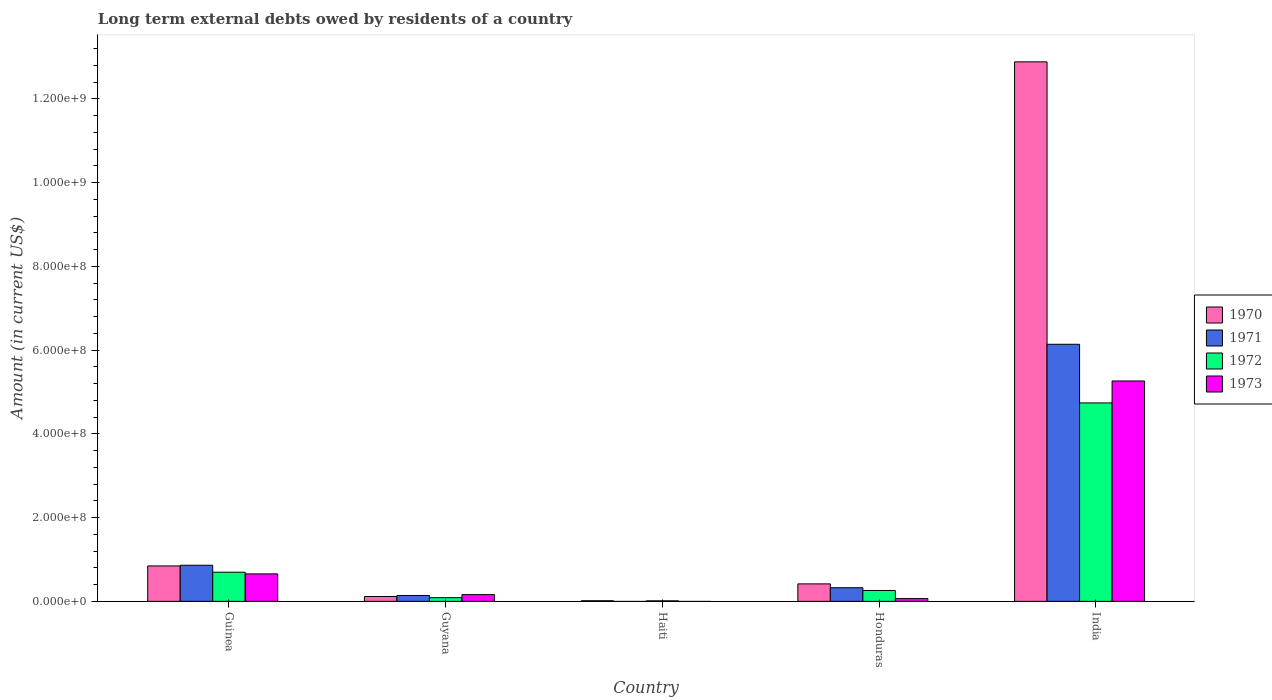Are the number of bars per tick equal to the number of legend labels?
Provide a succinct answer. No. Are the number of bars on each tick of the X-axis equal?
Provide a succinct answer. No. What is the label of the 5th group of bars from the left?
Provide a short and direct response. India. What is the amount of long-term external debts owed by residents in 1973 in Honduras?
Keep it short and to the point. 6.62e+06. Across all countries, what is the maximum amount of long-term external debts owed by residents in 1972?
Your answer should be compact. 4.74e+08. Across all countries, what is the minimum amount of long-term external debts owed by residents in 1971?
Offer a terse response. 0. In which country was the amount of long-term external debts owed by residents in 1971 maximum?
Provide a succinct answer. India. What is the total amount of long-term external debts owed by residents in 1971 in the graph?
Offer a terse response. 7.47e+08. What is the difference between the amount of long-term external debts owed by residents in 1971 in Guinea and that in India?
Your answer should be compact. -5.28e+08. What is the difference between the amount of long-term external debts owed by residents in 1971 in India and the amount of long-term external debts owed by residents in 1970 in Guyana?
Make the answer very short. 6.02e+08. What is the average amount of long-term external debts owed by residents in 1970 per country?
Give a very brief answer. 2.86e+08. What is the difference between the amount of long-term external debts owed by residents of/in 1970 and amount of long-term external debts owed by residents of/in 1971 in Guinea?
Ensure brevity in your answer.  -1.66e+06. In how many countries, is the amount of long-term external debts owed by residents in 1973 greater than 160000000 US$?
Offer a very short reply. 1. What is the ratio of the amount of long-term external debts owed by residents in 1970 in Guinea to that in Honduras?
Make the answer very short. 2.03. Is the difference between the amount of long-term external debts owed by residents in 1970 in Guyana and Honduras greater than the difference between the amount of long-term external debts owed by residents in 1971 in Guyana and Honduras?
Ensure brevity in your answer.  No. What is the difference between the highest and the second highest amount of long-term external debts owed by residents in 1973?
Your answer should be very brief. 4.61e+08. What is the difference between the highest and the lowest amount of long-term external debts owed by residents in 1970?
Your response must be concise. 1.29e+09. Is the sum of the amount of long-term external debts owed by residents in 1973 in Guyana and India greater than the maximum amount of long-term external debts owed by residents in 1972 across all countries?
Provide a short and direct response. Yes. Is it the case that in every country, the sum of the amount of long-term external debts owed by residents in 1971 and amount of long-term external debts owed by residents in 1973 is greater than the sum of amount of long-term external debts owed by residents in 1972 and amount of long-term external debts owed by residents in 1970?
Make the answer very short. No. Is it the case that in every country, the sum of the amount of long-term external debts owed by residents in 1972 and amount of long-term external debts owed by residents in 1970 is greater than the amount of long-term external debts owed by residents in 1973?
Offer a very short reply. Yes. Are all the bars in the graph horizontal?
Offer a terse response. No. How many countries are there in the graph?
Make the answer very short. 5. What is the difference between two consecutive major ticks on the Y-axis?
Keep it short and to the point. 2.00e+08. Does the graph contain grids?
Offer a very short reply. No. How many legend labels are there?
Your answer should be very brief. 4. What is the title of the graph?
Keep it short and to the point. Long term external debts owed by residents of a country. What is the label or title of the X-axis?
Your response must be concise. Country. What is the label or title of the Y-axis?
Provide a short and direct response. Amount (in current US$). What is the Amount (in current US$) of 1970 in Guinea?
Make the answer very short. 8.46e+07. What is the Amount (in current US$) in 1971 in Guinea?
Give a very brief answer. 8.63e+07. What is the Amount (in current US$) of 1972 in Guinea?
Make the answer very short. 6.96e+07. What is the Amount (in current US$) of 1973 in Guinea?
Give a very brief answer. 6.56e+07. What is the Amount (in current US$) in 1970 in Guyana?
Make the answer very short. 1.16e+07. What is the Amount (in current US$) in 1971 in Guyana?
Give a very brief answer. 1.40e+07. What is the Amount (in current US$) in 1972 in Guyana?
Offer a very short reply. 8.75e+06. What is the Amount (in current US$) in 1973 in Guyana?
Your answer should be compact. 1.61e+07. What is the Amount (in current US$) in 1970 in Haiti?
Make the answer very short. 1.51e+06. What is the Amount (in current US$) in 1971 in Haiti?
Your answer should be very brief. 0. What is the Amount (in current US$) of 1972 in Haiti?
Provide a succinct answer. 1.24e+06. What is the Amount (in current US$) in 1973 in Haiti?
Ensure brevity in your answer.  0. What is the Amount (in current US$) of 1970 in Honduras?
Provide a short and direct response. 4.17e+07. What is the Amount (in current US$) of 1971 in Honduras?
Keep it short and to the point. 3.26e+07. What is the Amount (in current US$) in 1972 in Honduras?
Offer a very short reply. 2.60e+07. What is the Amount (in current US$) of 1973 in Honduras?
Provide a short and direct response. 6.62e+06. What is the Amount (in current US$) of 1970 in India?
Provide a short and direct response. 1.29e+09. What is the Amount (in current US$) of 1971 in India?
Give a very brief answer. 6.14e+08. What is the Amount (in current US$) in 1972 in India?
Your answer should be compact. 4.74e+08. What is the Amount (in current US$) of 1973 in India?
Your answer should be very brief. 5.26e+08. Across all countries, what is the maximum Amount (in current US$) of 1970?
Your answer should be very brief. 1.29e+09. Across all countries, what is the maximum Amount (in current US$) of 1971?
Provide a short and direct response. 6.14e+08. Across all countries, what is the maximum Amount (in current US$) of 1972?
Keep it short and to the point. 4.74e+08. Across all countries, what is the maximum Amount (in current US$) of 1973?
Your answer should be very brief. 5.26e+08. Across all countries, what is the minimum Amount (in current US$) in 1970?
Keep it short and to the point. 1.51e+06. Across all countries, what is the minimum Amount (in current US$) of 1972?
Make the answer very short. 1.24e+06. Across all countries, what is the minimum Amount (in current US$) of 1973?
Your response must be concise. 0. What is the total Amount (in current US$) of 1970 in the graph?
Offer a very short reply. 1.43e+09. What is the total Amount (in current US$) of 1971 in the graph?
Give a very brief answer. 7.47e+08. What is the total Amount (in current US$) of 1972 in the graph?
Keep it short and to the point. 5.80e+08. What is the total Amount (in current US$) of 1973 in the graph?
Provide a succinct answer. 6.15e+08. What is the difference between the Amount (in current US$) of 1970 in Guinea and that in Guyana?
Offer a terse response. 7.30e+07. What is the difference between the Amount (in current US$) in 1971 in Guinea and that in Guyana?
Offer a terse response. 7.22e+07. What is the difference between the Amount (in current US$) of 1972 in Guinea and that in Guyana?
Your answer should be compact. 6.09e+07. What is the difference between the Amount (in current US$) in 1973 in Guinea and that in Guyana?
Offer a terse response. 4.95e+07. What is the difference between the Amount (in current US$) of 1970 in Guinea and that in Haiti?
Make the answer very short. 8.31e+07. What is the difference between the Amount (in current US$) in 1972 in Guinea and that in Haiti?
Your answer should be very brief. 6.84e+07. What is the difference between the Amount (in current US$) in 1970 in Guinea and that in Honduras?
Provide a short and direct response. 4.29e+07. What is the difference between the Amount (in current US$) of 1971 in Guinea and that in Honduras?
Provide a short and direct response. 5.37e+07. What is the difference between the Amount (in current US$) of 1972 in Guinea and that in Honduras?
Offer a very short reply. 4.36e+07. What is the difference between the Amount (in current US$) of 1973 in Guinea and that in Honduras?
Your answer should be compact. 5.90e+07. What is the difference between the Amount (in current US$) in 1970 in Guinea and that in India?
Your response must be concise. -1.20e+09. What is the difference between the Amount (in current US$) of 1971 in Guinea and that in India?
Your answer should be very brief. -5.28e+08. What is the difference between the Amount (in current US$) in 1972 in Guinea and that in India?
Your answer should be compact. -4.04e+08. What is the difference between the Amount (in current US$) in 1973 in Guinea and that in India?
Your answer should be compact. -4.61e+08. What is the difference between the Amount (in current US$) of 1970 in Guyana and that in Haiti?
Provide a succinct answer. 1.01e+07. What is the difference between the Amount (in current US$) in 1972 in Guyana and that in Haiti?
Offer a terse response. 7.52e+06. What is the difference between the Amount (in current US$) in 1970 in Guyana and that in Honduras?
Offer a very short reply. -3.01e+07. What is the difference between the Amount (in current US$) of 1971 in Guyana and that in Honduras?
Provide a succinct answer. -1.86e+07. What is the difference between the Amount (in current US$) in 1972 in Guyana and that in Honduras?
Ensure brevity in your answer.  -1.73e+07. What is the difference between the Amount (in current US$) in 1973 in Guyana and that in Honduras?
Make the answer very short. 9.47e+06. What is the difference between the Amount (in current US$) of 1970 in Guyana and that in India?
Offer a terse response. -1.28e+09. What is the difference between the Amount (in current US$) of 1971 in Guyana and that in India?
Offer a terse response. -6.00e+08. What is the difference between the Amount (in current US$) in 1972 in Guyana and that in India?
Make the answer very short. -4.65e+08. What is the difference between the Amount (in current US$) in 1973 in Guyana and that in India?
Your response must be concise. -5.10e+08. What is the difference between the Amount (in current US$) of 1970 in Haiti and that in Honduras?
Ensure brevity in your answer.  -4.02e+07. What is the difference between the Amount (in current US$) in 1972 in Haiti and that in Honduras?
Your response must be concise. -2.48e+07. What is the difference between the Amount (in current US$) in 1970 in Haiti and that in India?
Your response must be concise. -1.29e+09. What is the difference between the Amount (in current US$) in 1972 in Haiti and that in India?
Offer a very short reply. -4.73e+08. What is the difference between the Amount (in current US$) in 1970 in Honduras and that in India?
Your answer should be very brief. -1.25e+09. What is the difference between the Amount (in current US$) of 1971 in Honduras and that in India?
Your answer should be compact. -5.81e+08. What is the difference between the Amount (in current US$) in 1972 in Honduras and that in India?
Your answer should be compact. -4.48e+08. What is the difference between the Amount (in current US$) in 1973 in Honduras and that in India?
Your answer should be very brief. -5.20e+08. What is the difference between the Amount (in current US$) of 1970 in Guinea and the Amount (in current US$) of 1971 in Guyana?
Your response must be concise. 7.06e+07. What is the difference between the Amount (in current US$) of 1970 in Guinea and the Amount (in current US$) of 1972 in Guyana?
Your answer should be very brief. 7.58e+07. What is the difference between the Amount (in current US$) in 1970 in Guinea and the Amount (in current US$) in 1973 in Guyana?
Give a very brief answer. 6.85e+07. What is the difference between the Amount (in current US$) in 1971 in Guinea and the Amount (in current US$) in 1972 in Guyana?
Give a very brief answer. 7.75e+07. What is the difference between the Amount (in current US$) in 1971 in Guinea and the Amount (in current US$) in 1973 in Guyana?
Provide a short and direct response. 7.02e+07. What is the difference between the Amount (in current US$) of 1972 in Guinea and the Amount (in current US$) of 1973 in Guyana?
Ensure brevity in your answer.  5.35e+07. What is the difference between the Amount (in current US$) of 1970 in Guinea and the Amount (in current US$) of 1972 in Haiti?
Keep it short and to the point. 8.34e+07. What is the difference between the Amount (in current US$) in 1971 in Guinea and the Amount (in current US$) in 1972 in Haiti?
Keep it short and to the point. 8.50e+07. What is the difference between the Amount (in current US$) of 1970 in Guinea and the Amount (in current US$) of 1971 in Honduras?
Your answer should be compact. 5.20e+07. What is the difference between the Amount (in current US$) of 1970 in Guinea and the Amount (in current US$) of 1972 in Honduras?
Offer a terse response. 5.86e+07. What is the difference between the Amount (in current US$) of 1970 in Guinea and the Amount (in current US$) of 1973 in Honduras?
Make the answer very short. 7.80e+07. What is the difference between the Amount (in current US$) in 1971 in Guinea and the Amount (in current US$) in 1972 in Honduras?
Your answer should be compact. 6.03e+07. What is the difference between the Amount (in current US$) in 1971 in Guinea and the Amount (in current US$) in 1973 in Honduras?
Give a very brief answer. 7.96e+07. What is the difference between the Amount (in current US$) of 1972 in Guinea and the Amount (in current US$) of 1973 in Honduras?
Your response must be concise. 6.30e+07. What is the difference between the Amount (in current US$) in 1970 in Guinea and the Amount (in current US$) in 1971 in India?
Give a very brief answer. -5.29e+08. What is the difference between the Amount (in current US$) of 1970 in Guinea and the Amount (in current US$) of 1972 in India?
Offer a terse response. -3.89e+08. What is the difference between the Amount (in current US$) of 1970 in Guinea and the Amount (in current US$) of 1973 in India?
Ensure brevity in your answer.  -4.42e+08. What is the difference between the Amount (in current US$) of 1971 in Guinea and the Amount (in current US$) of 1972 in India?
Offer a terse response. -3.88e+08. What is the difference between the Amount (in current US$) in 1971 in Guinea and the Amount (in current US$) in 1973 in India?
Offer a very short reply. -4.40e+08. What is the difference between the Amount (in current US$) of 1972 in Guinea and the Amount (in current US$) of 1973 in India?
Ensure brevity in your answer.  -4.57e+08. What is the difference between the Amount (in current US$) in 1970 in Guyana and the Amount (in current US$) in 1972 in Haiti?
Your answer should be very brief. 1.04e+07. What is the difference between the Amount (in current US$) in 1971 in Guyana and the Amount (in current US$) in 1972 in Haiti?
Ensure brevity in your answer.  1.28e+07. What is the difference between the Amount (in current US$) in 1970 in Guyana and the Amount (in current US$) in 1971 in Honduras?
Provide a short and direct response. -2.10e+07. What is the difference between the Amount (in current US$) in 1970 in Guyana and the Amount (in current US$) in 1972 in Honduras?
Provide a short and direct response. -1.44e+07. What is the difference between the Amount (in current US$) of 1970 in Guyana and the Amount (in current US$) of 1973 in Honduras?
Ensure brevity in your answer.  5.00e+06. What is the difference between the Amount (in current US$) in 1971 in Guyana and the Amount (in current US$) in 1972 in Honduras?
Offer a terse response. -1.20e+07. What is the difference between the Amount (in current US$) of 1971 in Guyana and the Amount (in current US$) of 1973 in Honduras?
Offer a terse response. 7.42e+06. What is the difference between the Amount (in current US$) in 1972 in Guyana and the Amount (in current US$) in 1973 in Honduras?
Your response must be concise. 2.14e+06. What is the difference between the Amount (in current US$) of 1970 in Guyana and the Amount (in current US$) of 1971 in India?
Offer a terse response. -6.02e+08. What is the difference between the Amount (in current US$) of 1970 in Guyana and the Amount (in current US$) of 1972 in India?
Your response must be concise. -4.62e+08. What is the difference between the Amount (in current US$) in 1970 in Guyana and the Amount (in current US$) in 1973 in India?
Offer a terse response. -5.15e+08. What is the difference between the Amount (in current US$) in 1971 in Guyana and the Amount (in current US$) in 1972 in India?
Your response must be concise. -4.60e+08. What is the difference between the Amount (in current US$) of 1971 in Guyana and the Amount (in current US$) of 1973 in India?
Offer a very short reply. -5.12e+08. What is the difference between the Amount (in current US$) in 1972 in Guyana and the Amount (in current US$) in 1973 in India?
Provide a succinct answer. -5.18e+08. What is the difference between the Amount (in current US$) in 1970 in Haiti and the Amount (in current US$) in 1971 in Honduras?
Make the answer very short. -3.11e+07. What is the difference between the Amount (in current US$) of 1970 in Haiti and the Amount (in current US$) of 1972 in Honduras?
Provide a succinct answer. -2.45e+07. What is the difference between the Amount (in current US$) of 1970 in Haiti and the Amount (in current US$) of 1973 in Honduras?
Provide a succinct answer. -5.11e+06. What is the difference between the Amount (in current US$) in 1972 in Haiti and the Amount (in current US$) in 1973 in Honduras?
Make the answer very short. -5.38e+06. What is the difference between the Amount (in current US$) in 1970 in Haiti and the Amount (in current US$) in 1971 in India?
Provide a succinct answer. -6.12e+08. What is the difference between the Amount (in current US$) of 1970 in Haiti and the Amount (in current US$) of 1972 in India?
Your response must be concise. -4.72e+08. What is the difference between the Amount (in current US$) in 1970 in Haiti and the Amount (in current US$) in 1973 in India?
Your answer should be compact. -5.25e+08. What is the difference between the Amount (in current US$) of 1972 in Haiti and the Amount (in current US$) of 1973 in India?
Provide a succinct answer. -5.25e+08. What is the difference between the Amount (in current US$) of 1970 in Honduras and the Amount (in current US$) of 1971 in India?
Provide a succinct answer. -5.72e+08. What is the difference between the Amount (in current US$) of 1970 in Honduras and the Amount (in current US$) of 1972 in India?
Make the answer very short. -4.32e+08. What is the difference between the Amount (in current US$) in 1970 in Honduras and the Amount (in current US$) in 1973 in India?
Your answer should be very brief. -4.85e+08. What is the difference between the Amount (in current US$) of 1971 in Honduras and the Amount (in current US$) of 1972 in India?
Offer a very short reply. -4.41e+08. What is the difference between the Amount (in current US$) in 1971 in Honduras and the Amount (in current US$) in 1973 in India?
Keep it short and to the point. -4.94e+08. What is the difference between the Amount (in current US$) in 1972 in Honduras and the Amount (in current US$) in 1973 in India?
Ensure brevity in your answer.  -5.00e+08. What is the average Amount (in current US$) in 1970 per country?
Make the answer very short. 2.86e+08. What is the average Amount (in current US$) of 1971 per country?
Provide a short and direct response. 1.49e+08. What is the average Amount (in current US$) in 1972 per country?
Offer a very short reply. 1.16e+08. What is the average Amount (in current US$) in 1973 per country?
Make the answer very short. 1.23e+08. What is the difference between the Amount (in current US$) of 1970 and Amount (in current US$) of 1971 in Guinea?
Your answer should be compact. -1.66e+06. What is the difference between the Amount (in current US$) in 1970 and Amount (in current US$) in 1972 in Guinea?
Give a very brief answer. 1.50e+07. What is the difference between the Amount (in current US$) in 1970 and Amount (in current US$) in 1973 in Guinea?
Give a very brief answer. 1.90e+07. What is the difference between the Amount (in current US$) of 1971 and Amount (in current US$) of 1972 in Guinea?
Your answer should be compact. 1.66e+07. What is the difference between the Amount (in current US$) of 1971 and Amount (in current US$) of 1973 in Guinea?
Offer a very short reply. 2.06e+07. What is the difference between the Amount (in current US$) in 1970 and Amount (in current US$) in 1971 in Guyana?
Your answer should be very brief. -2.42e+06. What is the difference between the Amount (in current US$) of 1970 and Amount (in current US$) of 1972 in Guyana?
Your answer should be compact. 2.87e+06. What is the difference between the Amount (in current US$) in 1970 and Amount (in current US$) in 1973 in Guyana?
Your answer should be compact. -4.47e+06. What is the difference between the Amount (in current US$) in 1971 and Amount (in current US$) in 1972 in Guyana?
Your answer should be compact. 5.29e+06. What is the difference between the Amount (in current US$) of 1971 and Amount (in current US$) of 1973 in Guyana?
Make the answer very short. -2.05e+06. What is the difference between the Amount (in current US$) in 1972 and Amount (in current US$) in 1973 in Guyana?
Your response must be concise. -7.34e+06. What is the difference between the Amount (in current US$) of 1970 and Amount (in current US$) of 1972 in Haiti?
Make the answer very short. 2.72e+05. What is the difference between the Amount (in current US$) in 1970 and Amount (in current US$) in 1971 in Honduras?
Keep it short and to the point. 9.13e+06. What is the difference between the Amount (in current US$) of 1970 and Amount (in current US$) of 1972 in Honduras?
Make the answer very short. 1.57e+07. What is the difference between the Amount (in current US$) of 1970 and Amount (in current US$) of 1973 in Honduras?
Your answer should be compact. 3.51e+07. What is the difference between the Amount (in current US$) of 1971 and Amount (in current US$) of 1972 in Honduras?
Give a very brief answer. 6.59e+06. What is the difference between the Amount (in current US$) in 1971 and Amount (in current US$) in 1973 in Honduras?
Provide a short and direct response. 2.60e+07. What is the difference between the Amount (in current US$) of 1972 and Amount (in current US$) of 1973 in Honduras?
Provide a succinct answer. 1.94e+07. What is the difference between the Amount (in current US$) in 1970 and Amount (in current US$) in 1971 in India?
Ensure brevity in your answer.  6.74e+08. What is the difference between the Amount (in current US$) of 1970 and Amount (in current US$) of 1972 in India?
Provide a succinct answer. 8.15e+08. What is the difference between the Amount (in current US$) in 1970 and Amount (in current US$) in 1973 in India?
Your answer should be very brief. 7.62e+08. What is the difference between the Amount (in current US$) of 1971 and Amount (in current US$) of 1972 in India?
Keep it short and to the point. 1.40e+08. What is the difference between the Amount (in current US$) of 1971 and Amount (in current US$) of 1973 in India?
Your answer should be very brief. 8.77e+07. What is the difference between the Amount (in current US$) in 1972 and Amount (in current US$) in 1973 in India?
Your answer should be very brief. -5.24e+07. What is the ratio of the Amount (in current US$) of 1970 in Guinea to that in Guyana?
Make the answer very short. 7.28. What is the ratio of the Amount (in current US$) in 1971 in Guinea to that in Guyana?
Provide a succinct answer. 6.14. What is the ratio of the Amount (in current US$) of 1972 in Guinea to that in Guyana?
Provide a succinct answer. 7.96. What is the ratio of the Amount (in current US$) in 1973 in Guinea to that in Guyana?
Your response must be concise. 4.08. What is the ratio of the Amount (in current US$) in 1970 in Guinea to that in Haiti?
Your answer should be very brief. 56.14. What is the ratio of the Amount (in current US$) in 1972 in Guinea to that in Haiti?
Give a very brief answer. 56.37. What is the ratio of the Amount (in current US$) of 1970 in Guinea to that in Honduras?
Your answer should be very brief. 2.03. What is the ratio of the Amount (in current US$) of 1971 in Guinea to that in Honduras?
Your answer should be compact. 2.65. What is the ratio of the Amount (in current US$) in 1972 in Guinea to that in Honduras?
Provide a succinct answer. 2.68. What is the ratio of the Amount (in current US$) of 1973 in Guinea to that in Honduras?
Offer a very short reply. 9.92. What is the ratio of the Amount (in current US$) of 1970 in Guinea to that in India?
Keep it short and to the point. 0.07. What is the ratio of the Amount (in current US$) in 1971 in Guinea to that in India?
Ensure brevity in your answer.  0.14. What is the ratio of the Amount (in current US$) of 1972 in Guinea to that in India?
Offer a very short reply. 0.15. What is the ratio of the Amount (in current US$) in 1973 in Guinea to that in India?
Offer a terse response. 0.12. What is the ratio of the Amount (in current US$) in 1970 in Guyana to that in Haiti?
Make the answer very short. 7.71. What is the ratio of the Amount (in current US$) in 1972 in Guyana to that in Haiti?
Ensure brevity in your answer.  7.09. What is the ratio of the Amount (in current US$) in 1970 in Guyana to that in Honduras?
Your answer should be compact. 0.28. What is the ratio of the Amount (in current US$) in 1971 in Guyana to that in Honduras?
Provide a succinct answer. 0.43. What is the ratio of the Amount (in current US$) of 1972 in Guyana to that in Honduras?
Ensure brevity in your answer.  0.34. What is the ratio of the Amount (in current US$) in 1973 in Guyana to that in Honduras?
Your answer should be very brief. 2.43. What is the ratio of the Amount (in current US$) in 1970 in Guyana to that in India?
Your answer should be compact. 0.01. What is the ratio of the Amount (in current US$) in 1971 in Guyana to that in India?
Your answer should be compact. 0.02. What is the ratio of the Amount (in current US$) in 1972 in Guyana to that in India?
Your response must be concise. 0.02. What is the ratio of the Amount (in current US$) in 1973 in Guyana to that in India?
Your answer should be compact. 0.03. What is the ratio of the Amount (in current US$) of 1970 in Haiti to that in Honduras?
Give a very brief answer. 0.04. What is the ratio of the Amount (in current US$) of 1972 in Haiti to that in Honduras?
Provide a succinct answer. 0.05. What is the ratio of the Amount (in current US$) in 1970 in Haiti to that in India?
Your response must be concise. 0. What is the ratio of the Amount (in current US$) of 1972 in Haiti to that in India?
Make the answer very short. 0. What is the ratio of the Amount (in current US$) in 1970 in Honduras to that in India?
Your answer should be compact. 0.03. What is the ratio of the Amount (in current US$) in 1971 in Honduras to that in India?
Your response must be concise. 0.05. What is the ratio of the Amount (in current US$) of 1972 in Honduras to that in India?
Offer a very short reply. 0.05. What is the ratio of the Amount (in current US$) in 1973 in Honduras to that in India?
Provide a short and direct response. 0.01. What is the difference between the highest and the second highest Amount (in current US$) of 1970?
Provide a short and direct response. 1.20e+09. What is the difference between the highest and the second highest Amount (in current US$) in 1971?
Offer a very short reply. 5.28e+08. What is the difference between the highest and the second highest Amount (in current US$) of 1972?
Make the answer very short. 4.04e+08. What is the difference between the highest and the second highest Amount (in current US$) of 1973?
Ensure brevity in your answer.  4.61e+08. What is the difference between the highest and the lowest Amount (in current US$) in 1970?
Give a very brief answer. 1.29e+09. What is the difference between the highest and the lowest Amount (in current US$) of 1971?
Offer a terse response. 6.14e+08. What is the difference between the highest and the lowest Amount (in current US$) of 1972?
Ensure brevity in your answer.  4.73e+08. What is the difference between the highest and the lowest Amount (in current US$) in 1973?
Provide a succinct answer. 5.26e+08. 